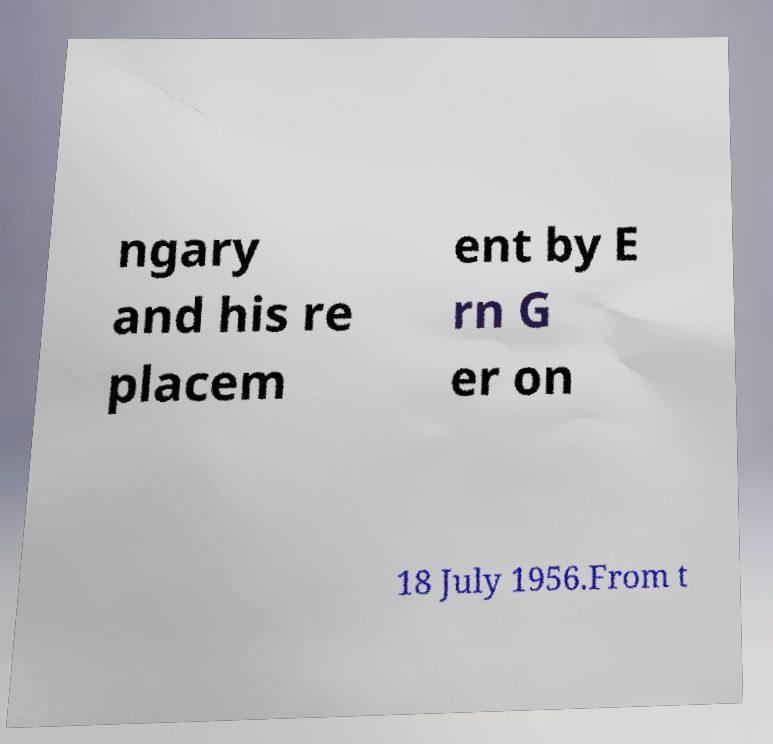There's text embedded in this image that I need extracted. Can you transcribe it verbatim? ngary and his re placem ent by E rn G er on 18 July 1956.From t 